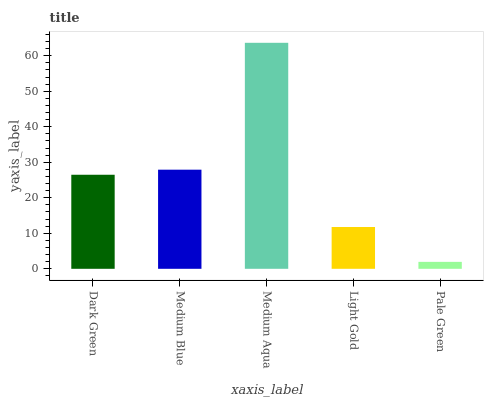Is Medium Blue the minimum?
Answer yes or no. No. Is Medium Blue the maximum?
Answer yes or no. No. Is Medium Blue greater than Dark Green?
Answer yes or no. Yes. Is Dark Green less than Medium Blue?
Answer yes or no. Yes. Is Dark Green greater than Medium Blue?
Answer yes or no. No. Is Medium Blue less than Dark Green?
Answer yes or no. No. Is Dark Green the high median?
Answer yes or no. Yes. Is Dark Green the low median?
Answer yes or no. Yes. Is Pale Green the high median?
Answer yes or no. No. Is Pale Green the low median?
Answer yes or no. No. 